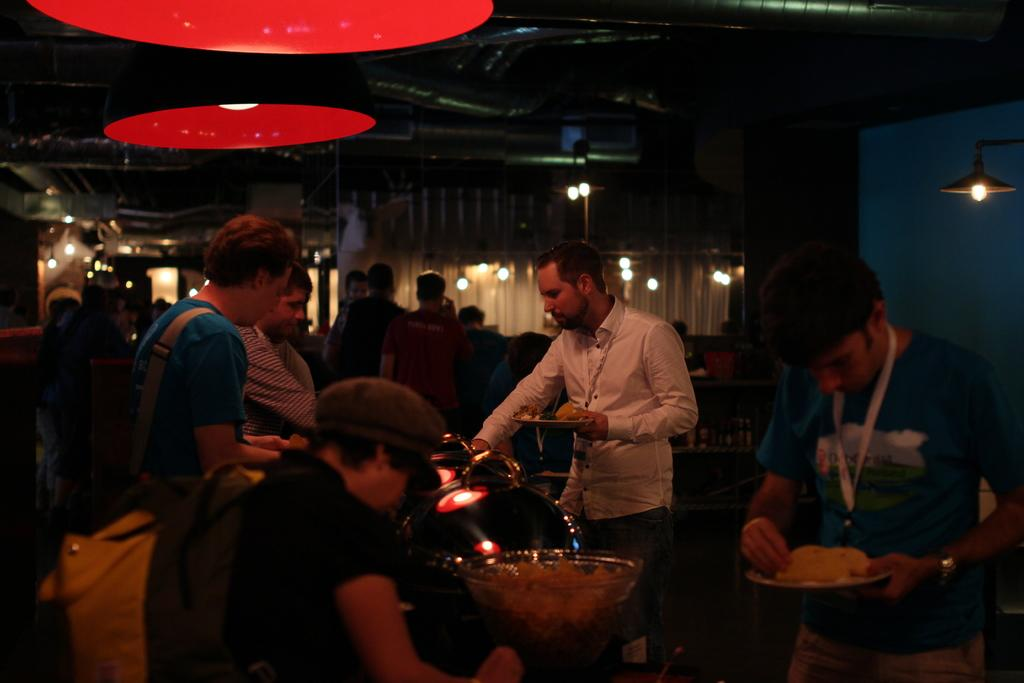Who or what is present in the image? There are people in the image. What objects can be seen in the image? There are lights and bowls in the image. What can be found in the background of the image? The background of the image includes curtains. What color is the wall on the right side of the image? The wall on the right side of the image is blue. How would you describe the lighting in the image? The image is slightly dark. Where is the shelf located in the image? There is no shelf present in the image. What type of control is being used by the people in the image? There is no control being used by the people in the image. Is there a church visible in the image? There is no church present in the image. 